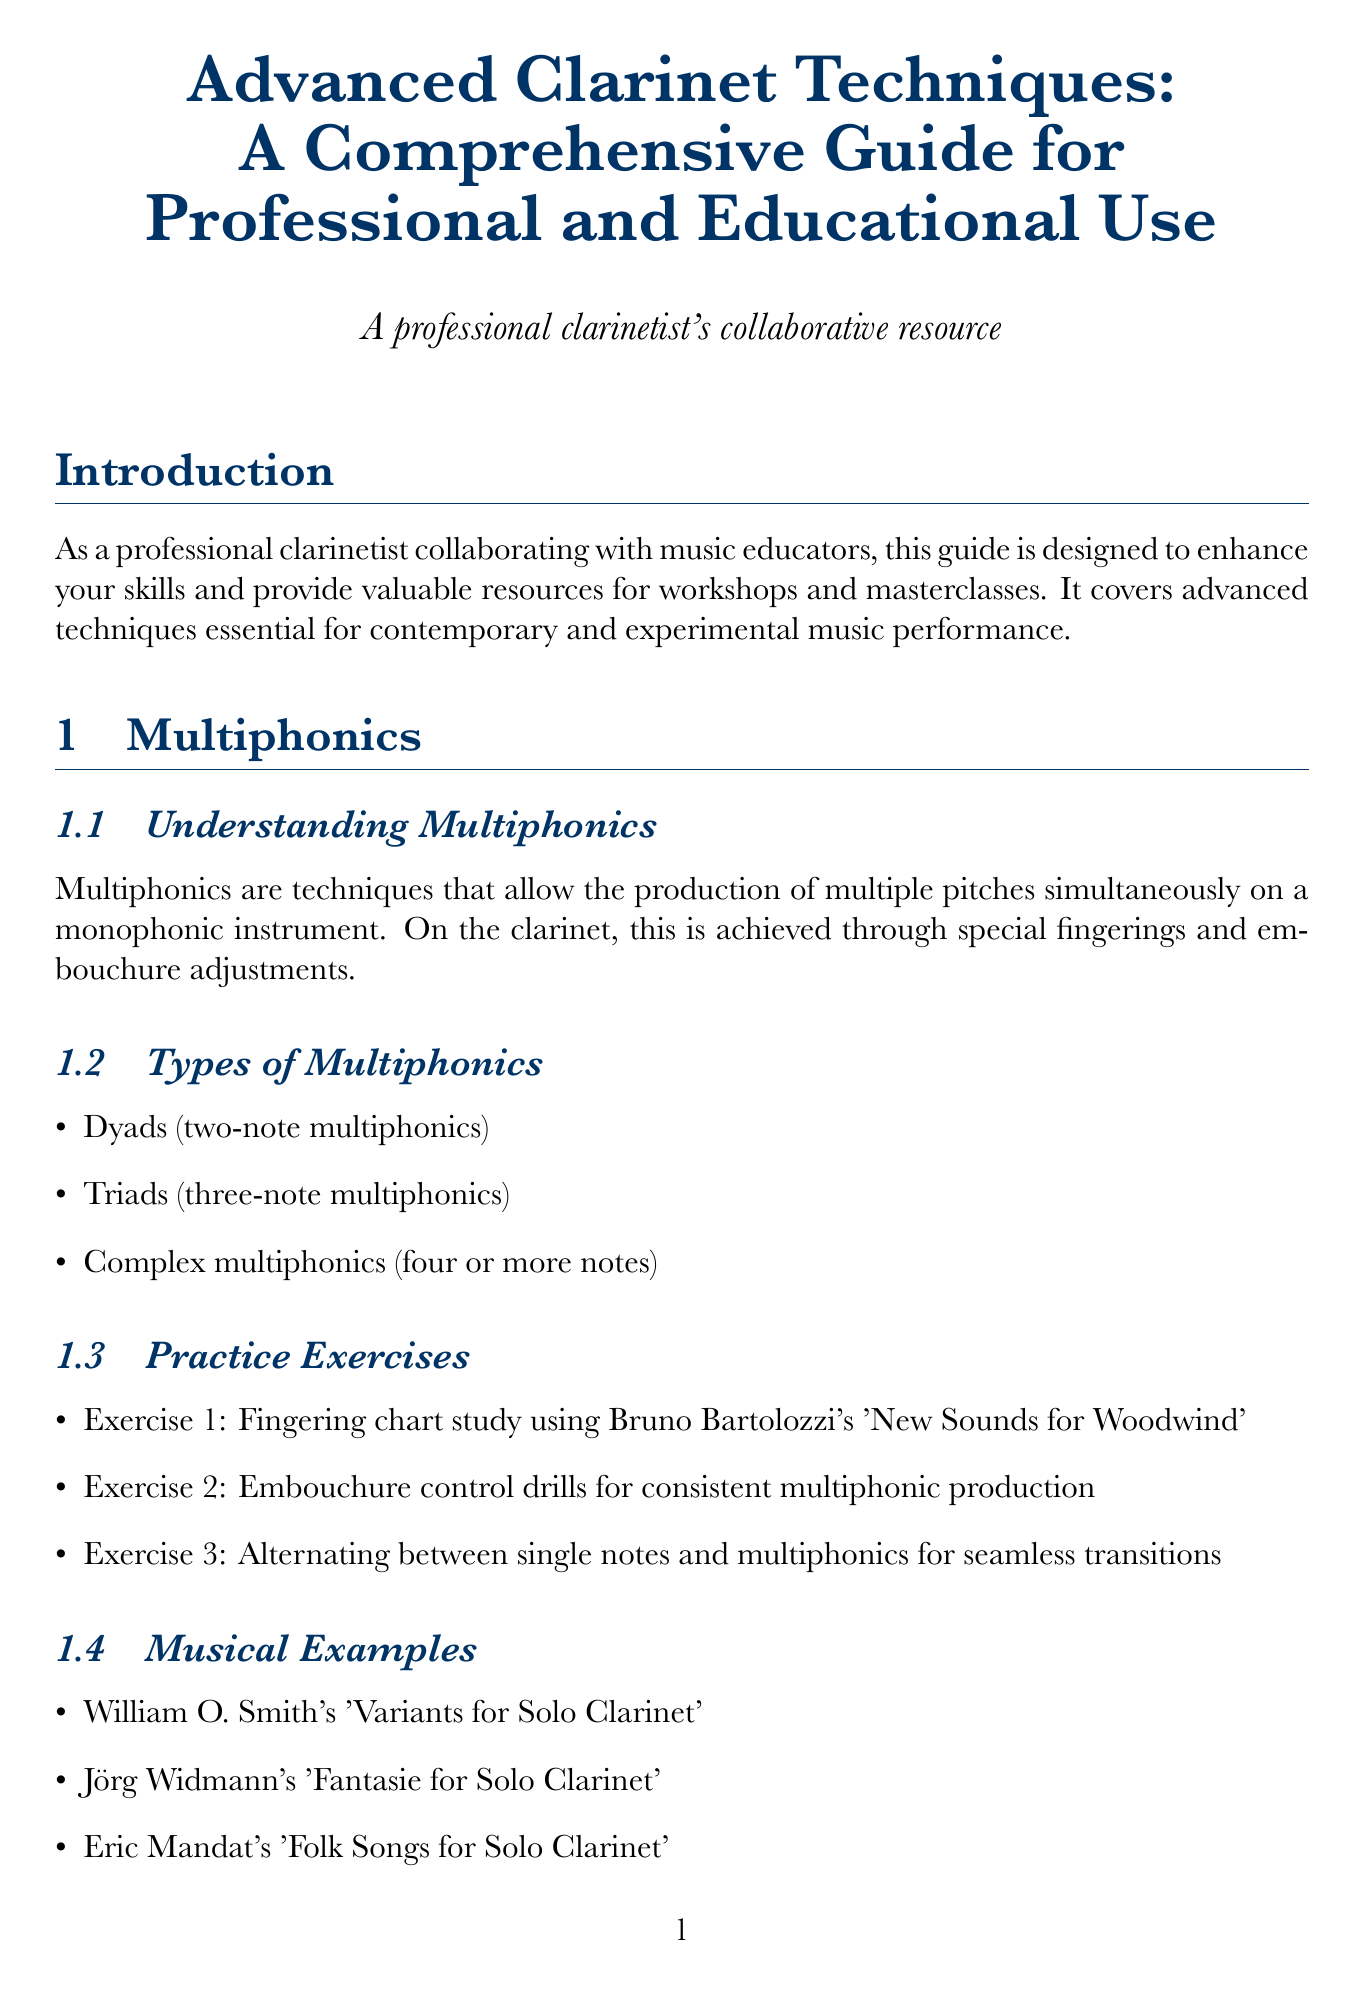What is the title of the document? The title of the document is presented at the beginning and is "Advanced Clarinet Techniques: A Comprehensive Guide for Professional and Educational Use."
Answer: Advanced Clarinet Techniques: A Comprehensive Guide for Professional and Educational Use How many main sections are there in the document? Counting the main sections listed, there are seven sections in total: Introduction, Multiphonics, Circular Breathing, Extended Techniques, Implementing Techniques in Performance and Education, Equipment and Maintenance, and Conclusion.
Answer: 7 What technique allows continuous sound production without interruption for breath? This document describes circular breathing as the technique that allows continuous sound production without interruption.
Answer: Circular breathing Name one composer associated with musical examples for circular breathing techniques. Anton Stadler's Clarinet Concerto by Mozart is mentioned as a musical example for circular breathing techniques.
Answer: Anton Stadler What type of multiphonics involves two notes? The document specifies that dyads represent two-note multiphonics.
Answer: Dyads What is one suggested workshop idea in the document? A workshop idea suggested in the document includes an interactive multiphonics exploration session.
Answer: Interactive multiphonics exploration session Which mouthpiece is recommended for multiphonics? The document recommends using the Vandoren M30 mouthpiece for multiphonics.
Answer: Vandoren M30 What is the content of the "Conclusion" section? The Conclusion section emphasizes the importance of ongoing exploration and integration of advanced techniques in performance and education.
Answer: Encouragement for continued exploration and integration of advanced techniques in both performance and educational settings 